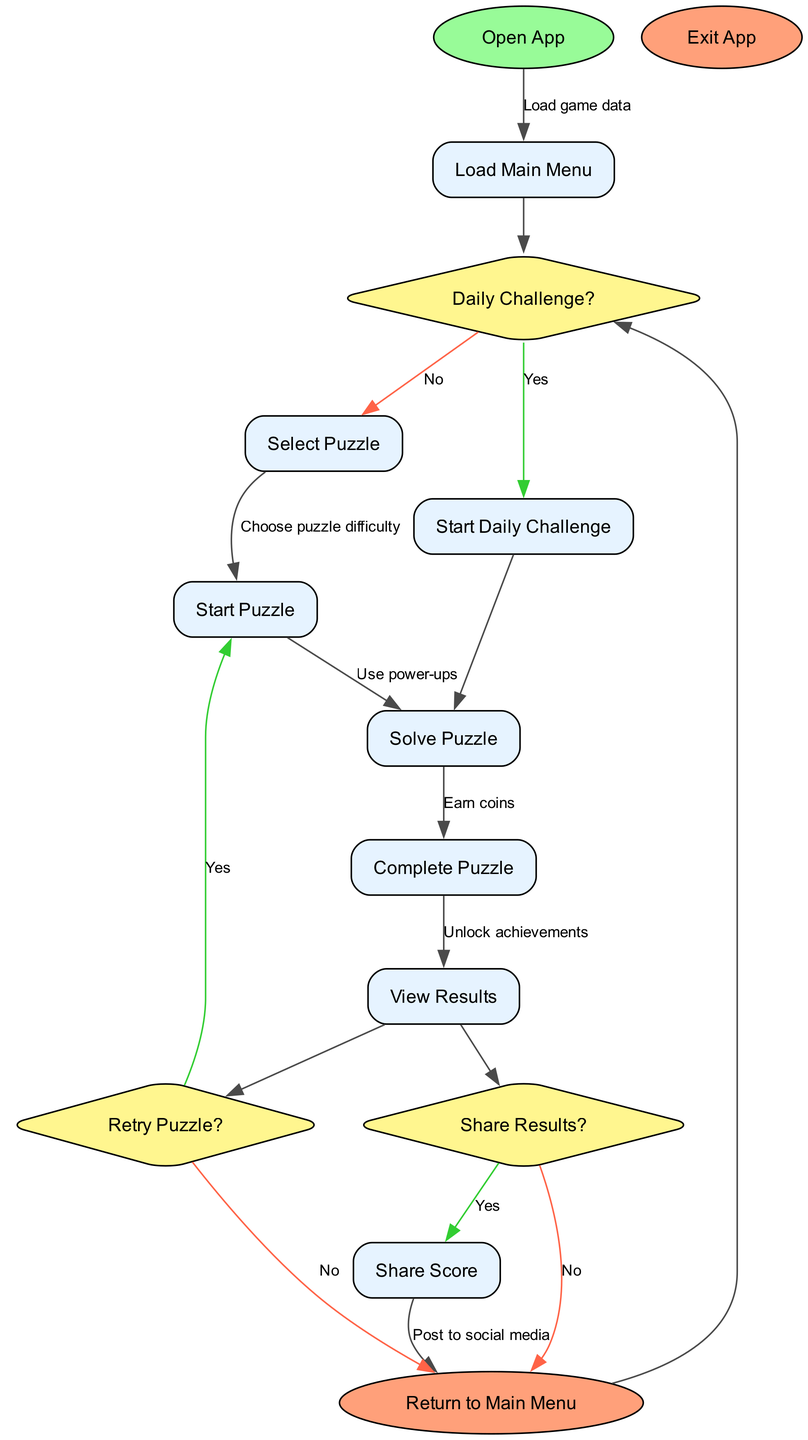What is the first activity in the engagement loop? The engagement loop starts at the initial node labeled "Open App". This is where the player begins interacting with the game.
Answer: Open App How many edges connect to the "Load Main Menu" node? The "Load Main Menu" node has one outgoing edge that connects to the "Daily Challenge?" decision node. It indicates the flow from loading the game data into the main menu.
Answer: 1 What is the last activity before a player may share their score? The last activity before sharing a score is "View Results". After solving a puzzle, players can view their results, which precedes the option to share.
Answer: View Results If a player chooses to retry a puzzle, what node do they return to? If a player selects "yes" for the "Retry Puzzle?" decision, they will return to the "Start Puzzle" node to attempt the same puzzle again.
Answer: Start Puzzle What happens if a player does not choose to share their results? If the player decides not to share their results, they will return to the "Return to Main Menu" node, exiting the sharing option entirely.
Answer: Return to Main Menu What are the options available after completing a puzzle? After completing a puzzle, the player can either continue to "View Results" or choose to "Retry Puzzle?". This shows two pathways available for the player post-puzzle completion.
Answer: View Results, Retry Puzzle? How does a player initiate a daily challenge? A player can start a daily challenge by answering "yes" to the "Daily Challenge?" decision, which flows directly into the "Start Daily Challenge" node.
Answer: Start Daily Challenge What are two activities a player can choose after loading the main menu? After loading the main menu, a player can either select a specific puzzle or start a daily challenge if they choose to engage with the daily content.
Answer: Select Puzzle, Start Daily Challenge How does a player unlock achievements during gameplay? Players unlock achievements through successful gameplay, which typically occurs during or after completing puzzles—indicated in the flow by the edge labeled "Unlock achievements".
Answer: During gameplay 